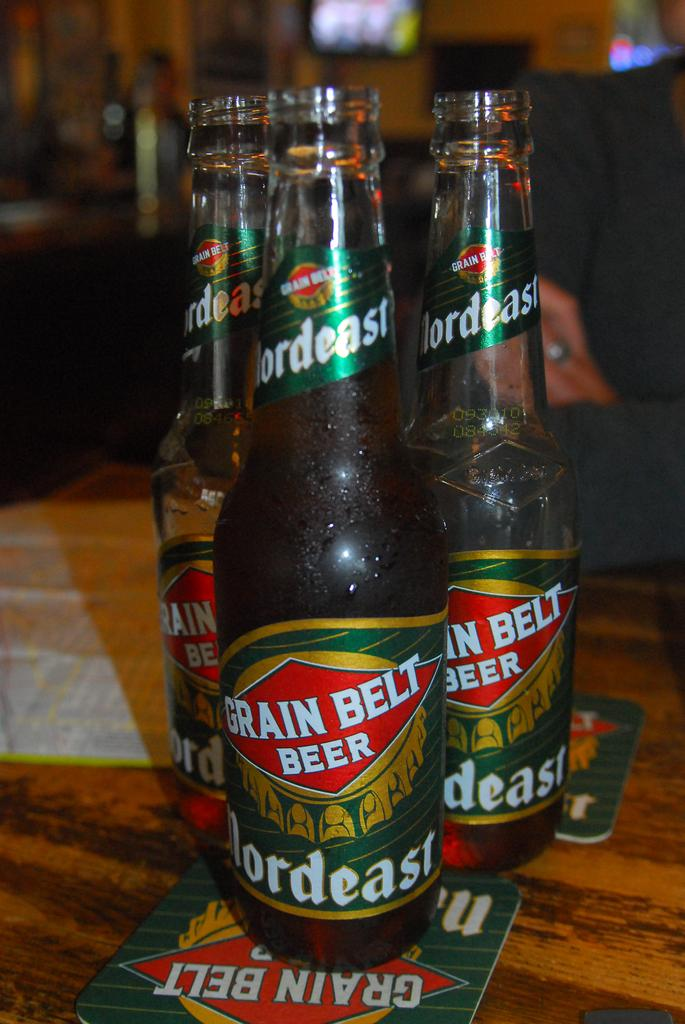<image>
Present a compact description of the photo's key features. 3 bottles of grain belt beer next to each other 